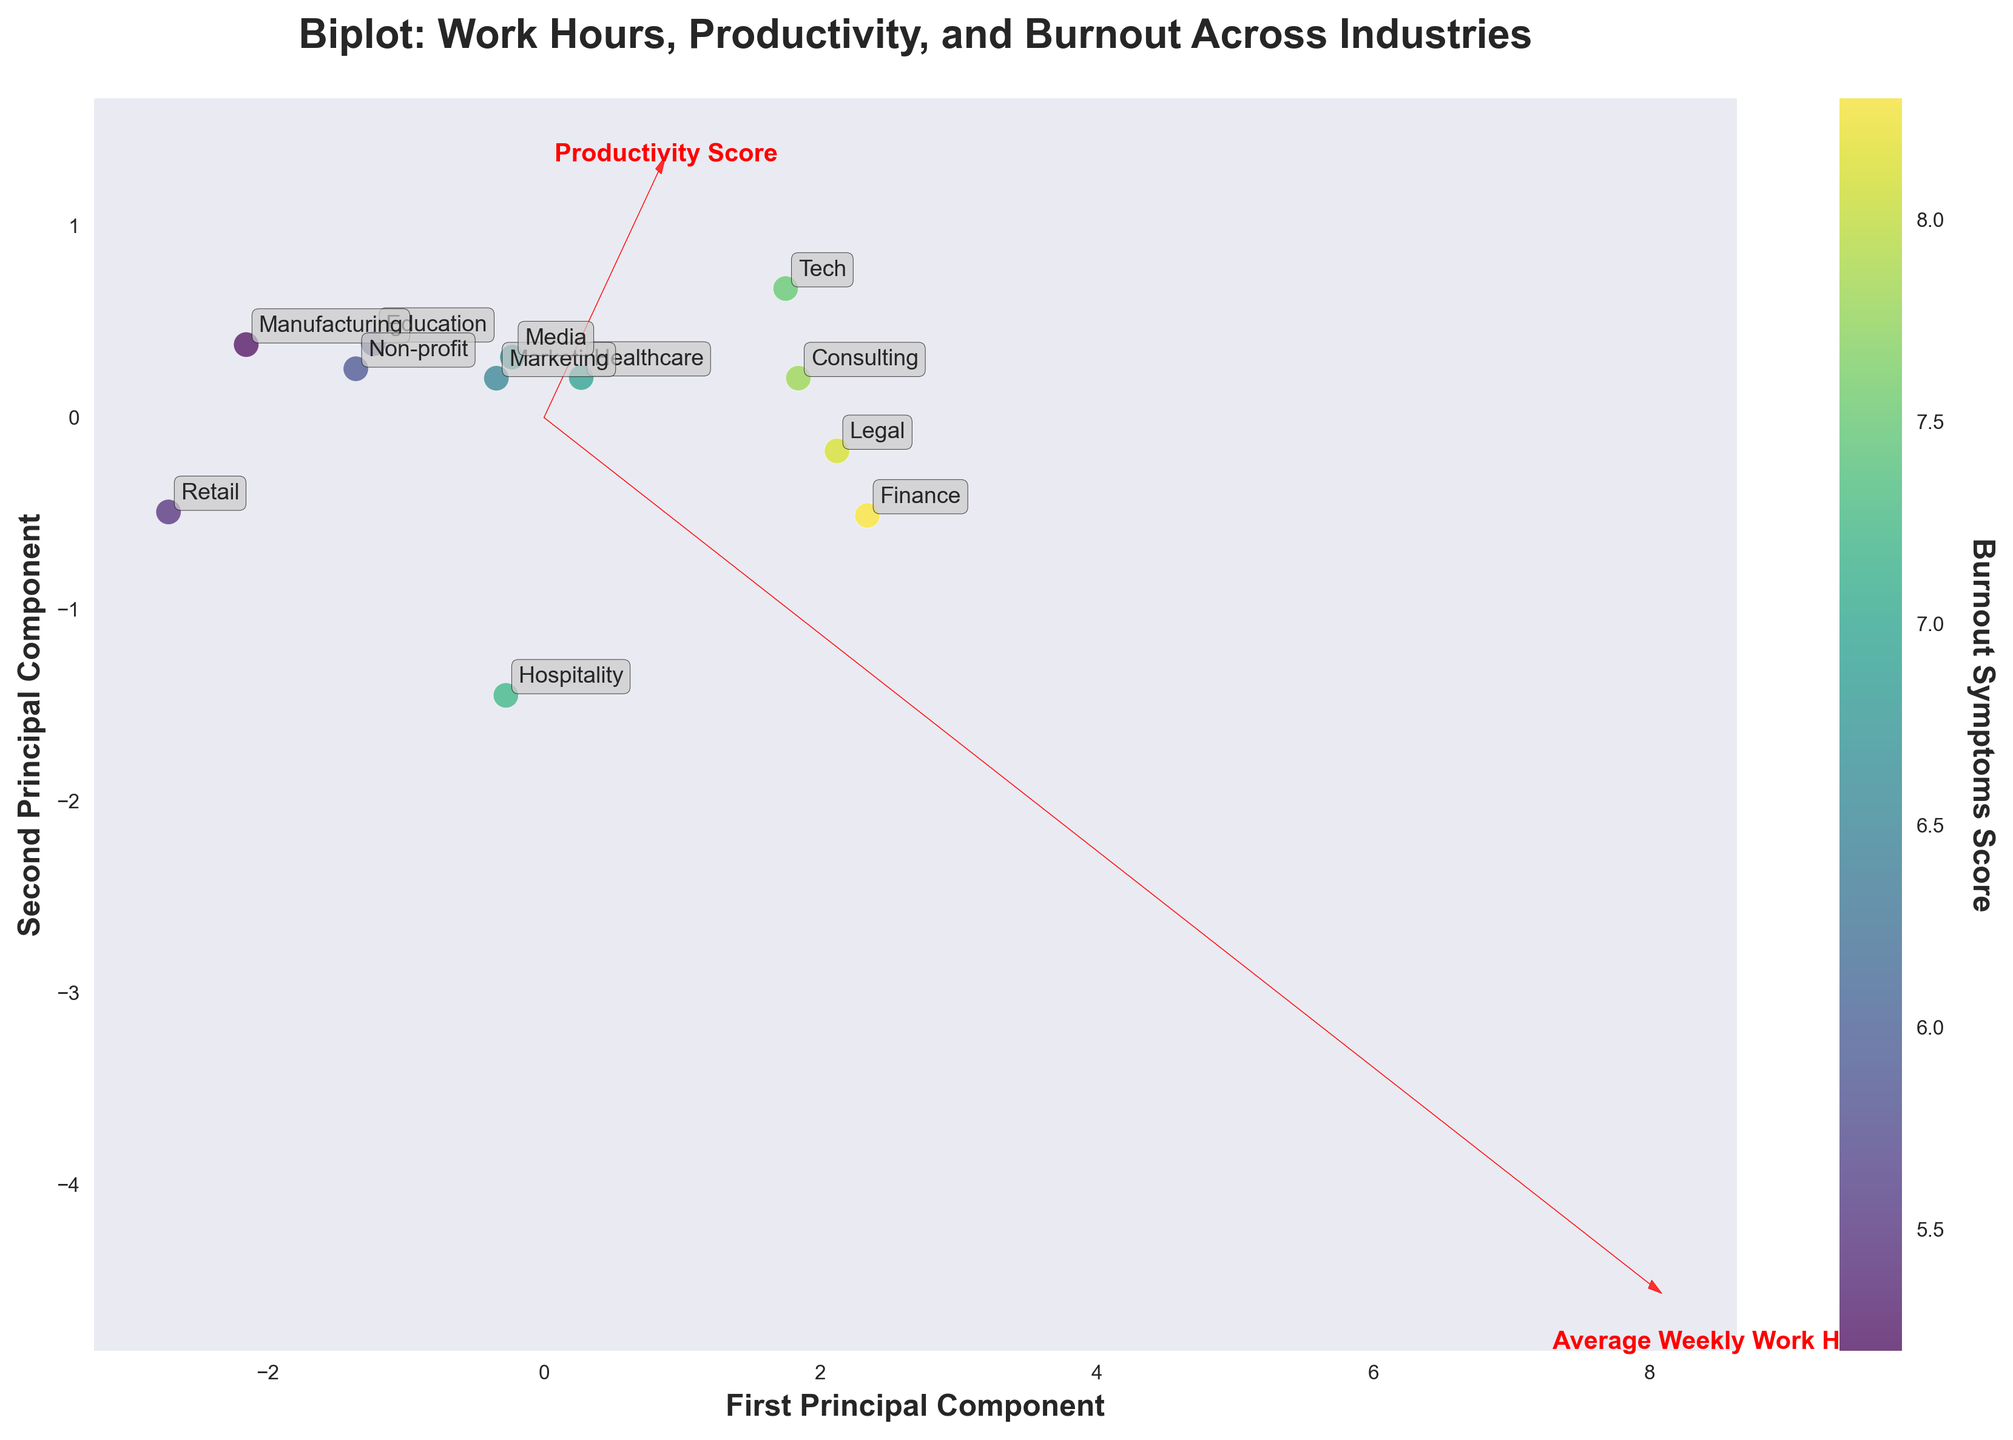What does the color bar represent in the plot? The color bar to the right of the plot represents the 'Burnout Symptoms Score' of the industries. The colors vary according to these scores, with higher scores corresponding to a different color intensity.
Answer: Burnout Symptoms Score How many industries are represented in the plot? There are individual points on the plot, each labeled with an industry. By counting these labels, we see that there are 12 distinct industries represented.
Answer: 12 Which industry has the highest average weekly work hours? By looking at the annotations, the Finance industry is placed farthest to the right along the 'Average Weekly Work Hours' vector.
Answer: Finance Which industry has the lowest productivity score? The Retail industry is located furthest to the left along the 'Productivity Score' vector, indicating the lowest productivity.
Answer: Retail How are 'Average Weekly Work Hours' and 'Burnout Symptoms Score' vectors oriented relative to each other? The vectors for the 'Average Weekly Work Hours' and 'Burnout Symptoms Score' are oriented very similarly, indicating a potential positive correlation between the two.
Answer: Positively correlated Which industry has a high productivity score but relatively lower burnout symptoms? By identifying points with a high 'Productivity Score' that are colored closer to the lower end of the color bar, the Tech industry appears to fit this criterion.
Answer: Tech What is the relationship between work hours and productivity in the plot? The vectors for 'Average Weekly Work Hours' and 'Productivity Score' are slightly divergent, suggesting there isn't a strong direct correlation between work hours and productivity.
Answer: Weak/no direct correlation Which two industries are closest to each other in the biplot? By observing their positions, the Tech and Consulting industries are the closest to each other in the biplot.
Answer: Tech and Consulting Is there an industry with low work hours but high burnout symptoms? The Hospitality industry has relatively lower work hours (below average) but higher burnout symptoms, as shown by its position on the plot and its color on the color bar.
Answer: Hospitality 